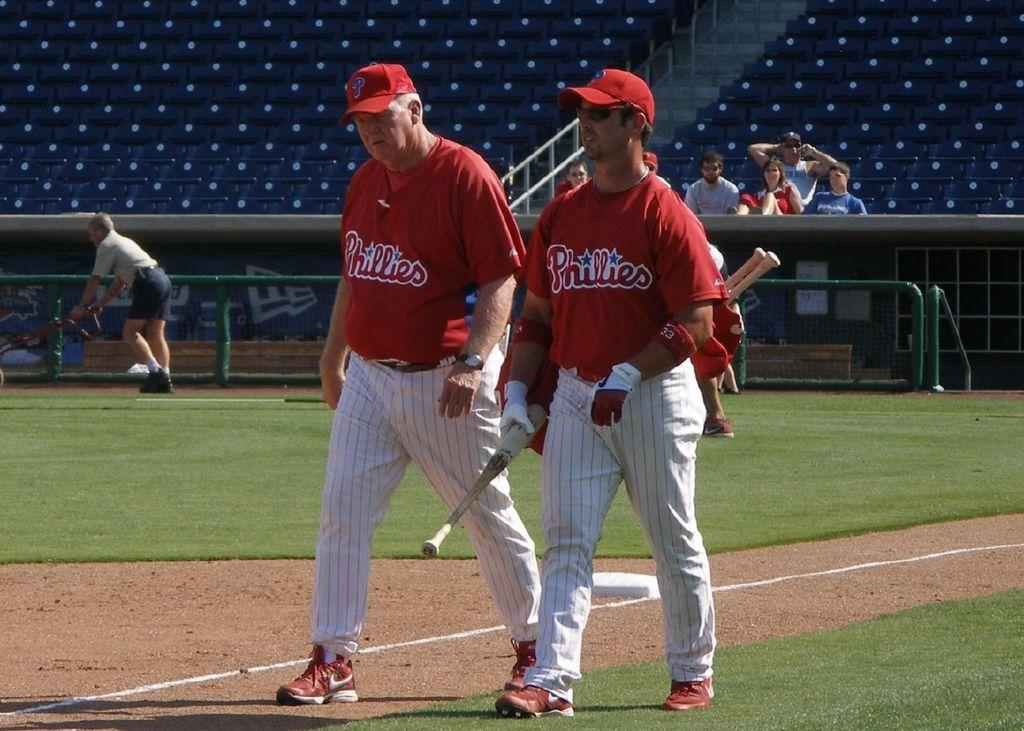<image>
Give a short and clear explanation of the subsequent image. Two men, whose shirts read Phillies, stand on a baseball field. 